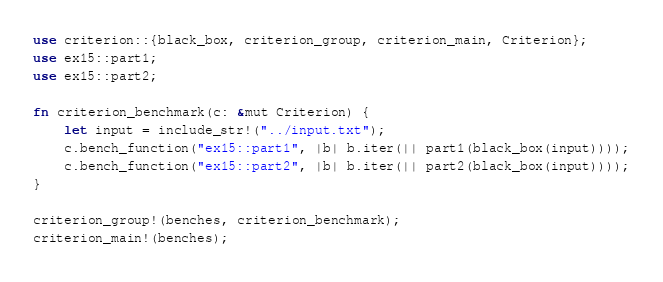Convert code to text. <code><loc_0><loc_0><loc_500><loc_500><_Rust_>use criterion::{black_box, criterion_group, criterion_main, Criterion};
use ex15::part1;
use ex15::part2;

fn criterion_benchmark(c: &mut Criterion) {
    let input = include_str!("../input.txt");
    c.bench_function("ex15::part1", |b| b.iter(|| part1(black_box(input))));
    c.bench_function("ex15::part2", |b| b.iter(|| part2(black_box(input))));
}

criterion_group!(benches, criterion_benchmark);
criterion_main!(benches);
</code> 